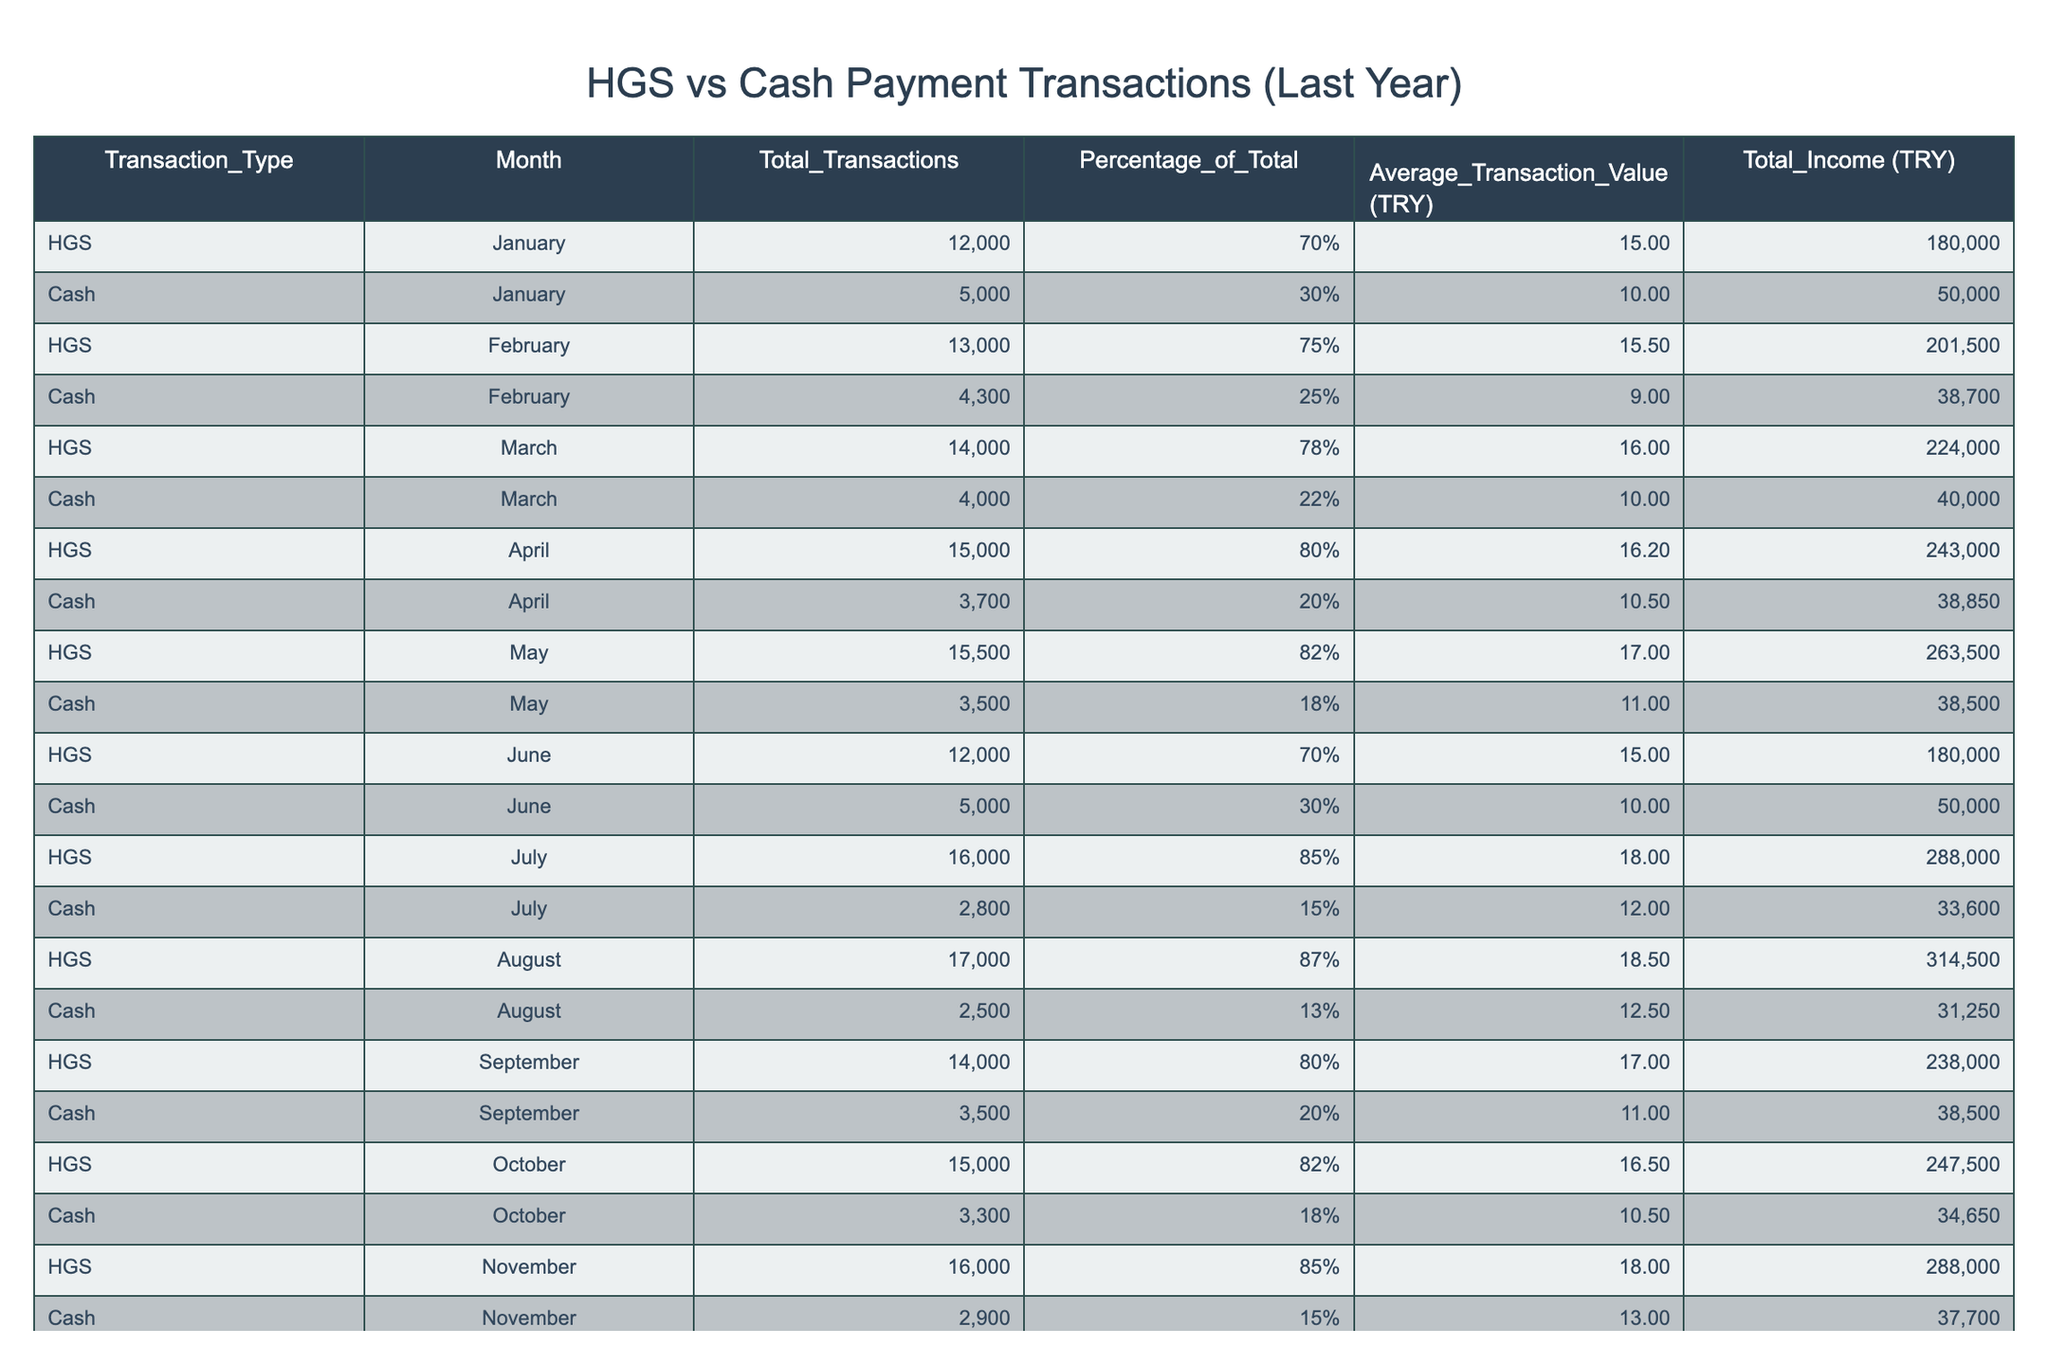What was the total income from HGS transactions in December? The total income from HGS transactions in December is provided directly in the table under the column "Total_Income (TRY)," where it states 332500.
Answer: 332500 How many total cash transactions were recorded in June? The table shows the total cash transactions for June under the column "Total_Transactions," which indicates 5000 transactions.
Answer: 5000 Which month had the highest average transaction value for cash payments? To find the month with the highest average transaction value, I compare the "Average_Transaction_Value (TRY)" for cash across all months and find August, which has an average of 12.5.
Answer: August What is the percentage of total transactions that were HGS in July? The table specifies that for July, the percentage of total transactions that were HGS is 85%, as indicated in the column "Percentage_of_Total."
Answer: 85% What was the total income from cash payments for the entire year? To find the total income from cash payments, I sum the "Total_Income (TRY)" for all months where the transaction type is cash: 50000 + 38700 + 40000 + 38850 + 38500 + 50000 + 33600 + 31250 + 38500 + 34650 + 37700 + 24000, which totals to 340250.
Answer: 340250 In which month did HGS transactions exceed cash transactions by the highest amount? To determine this, I will calculate the difference between HGS and cash transactions for each month. For example, in December: HGS has 17500 and cash has 2000, which gives a difference of 15500. Looping through each month, this highest difference is found in July: 16000 - 2800 = 13200.
Answer: July Did cash transactions ever exceed HGS transactions in any month? I will review the total transactions for both HGS and cash for each month. The table shows that cash never exceeds HGS in any month, indicating no month had cash transactions greater than HGS.
Answer: No What was the average total income for HGS transactions over the year? To calculate the average total income for HGS, I sum all the total incomes for HGS transactions from the table (180000 + 201500 + 224000 + 243000 + 263500 + 180000 + 288000 + 314500 + 238000 + 247500 + 288000 + 332500) and divide by the number of months (12), which gives an average of 243208.33.
Answer: 243208.33 